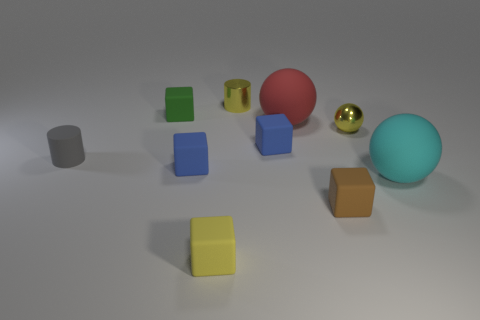There is a cube that is the same color as the tiny metal sphere; what material is it?
Keep it short and to the point. Rubber. What is the size of the rubber thing that is the same color as the metal cylinder?
Give a very brief answer. Small. The small object that is made of the same material as the yellow cylinder is what color?
Make the answer very short. Yellow. Are there more tiny purple balls than blue cubes?
Offer a very short reply. No. Are there any tiny shiny spheres?
Provide a short and direct response. Yes. What shape is the blue matte object on the right side of the small blue matte cube that is in front of the gray cylinder?
Offer a terse response. Cube. How many things are tiny blue rubber cubes or blue blocks that are to the left of the yellow block?
Your answer should be compact. 2. There is a metal object behind the rubber thing behind the matte ball left of the cyan sphere; what color is it?
Provide a succinct answer. Yellow. There is a yellow thing that is the same shape as the cyan thing; what is its material?
Offer a very short reply. Metal. The metal sphere is what color?
Keep it short and to the point. Yellow. 